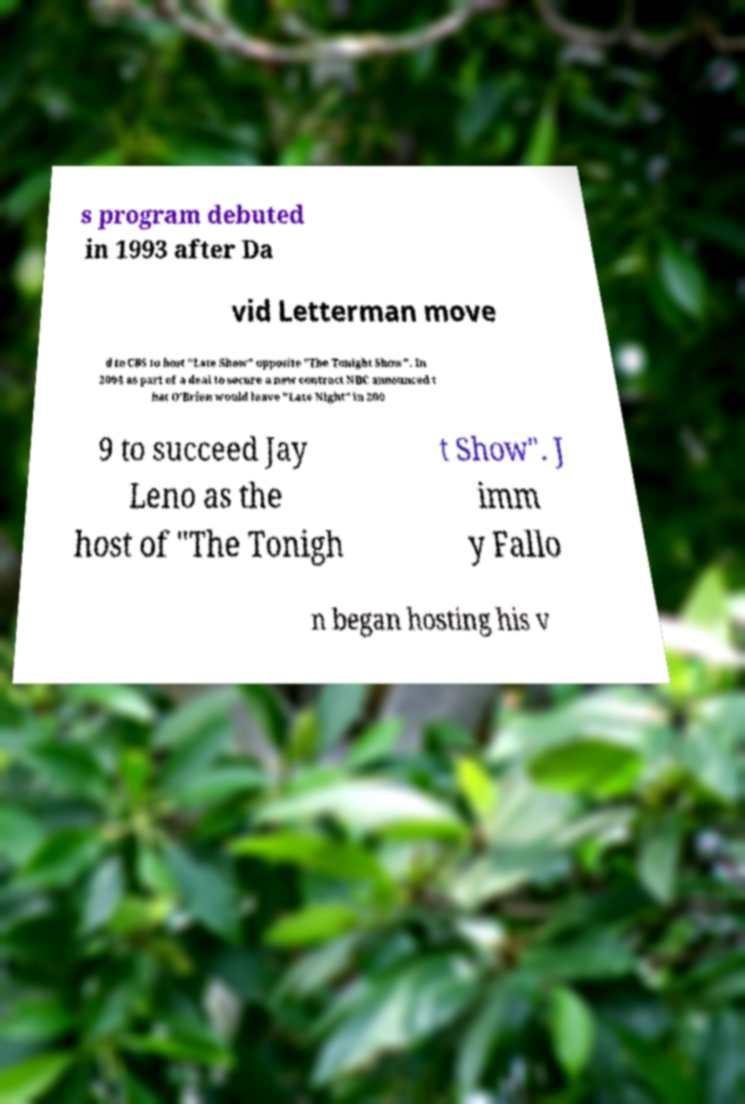Can you read and provide the text displayed in the image?This photo seems to have some interesting text. Can you extract and type it out for me? s program debuted in 1993 after Da vid Letterman move d to CBS to host "Late Show" opposite "The Tonight Show". In 2004 as part of a deal to secure a new contract NBC announced t hat O'Brien would leave "Late Night" in 200 9 to succeed Jay Leno as the host of "The Tonigh t Show". J imm y Fallo n began hosting his v 